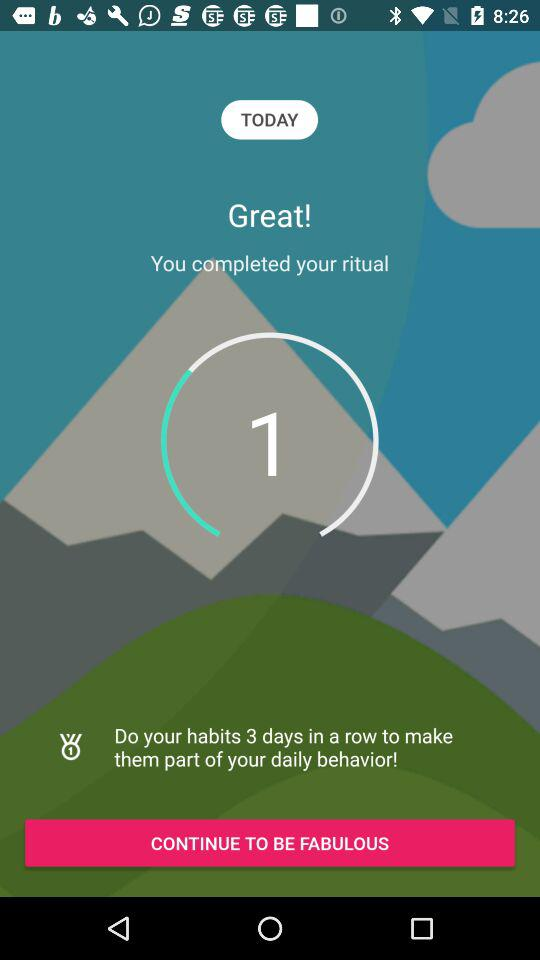How many more days do I need to do my habit to make it part of my daily behavior?
Answer the question using a single word or phrase. 2 